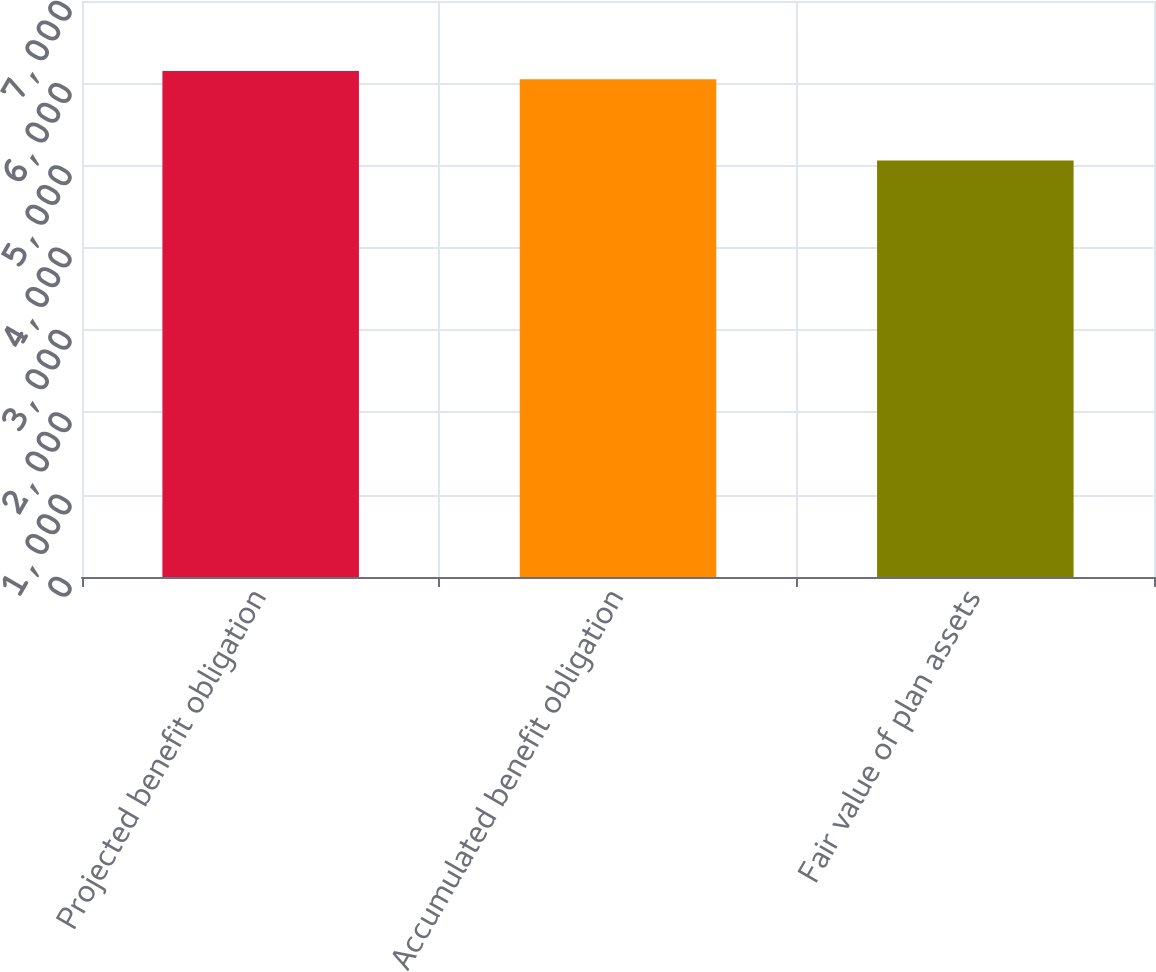Convert chart to OTSL. <chart><loc_0><loc_0><loc_500><loc_500><bar_chart><fcel>Projected benefit obligation<fcel>Accumulated benefit obligation<fcel>Fair value of plan assets<nl><fcel>6149.8<fcel>6049<fcel>5063<nl></chart> 